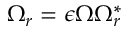Convert formula to latex. <formula><loc_0><loc_0><loc_500><loc_500>\Omega _ { r } = \epsilon \Omega \Omega _ { r } ^ { * }</formula> 